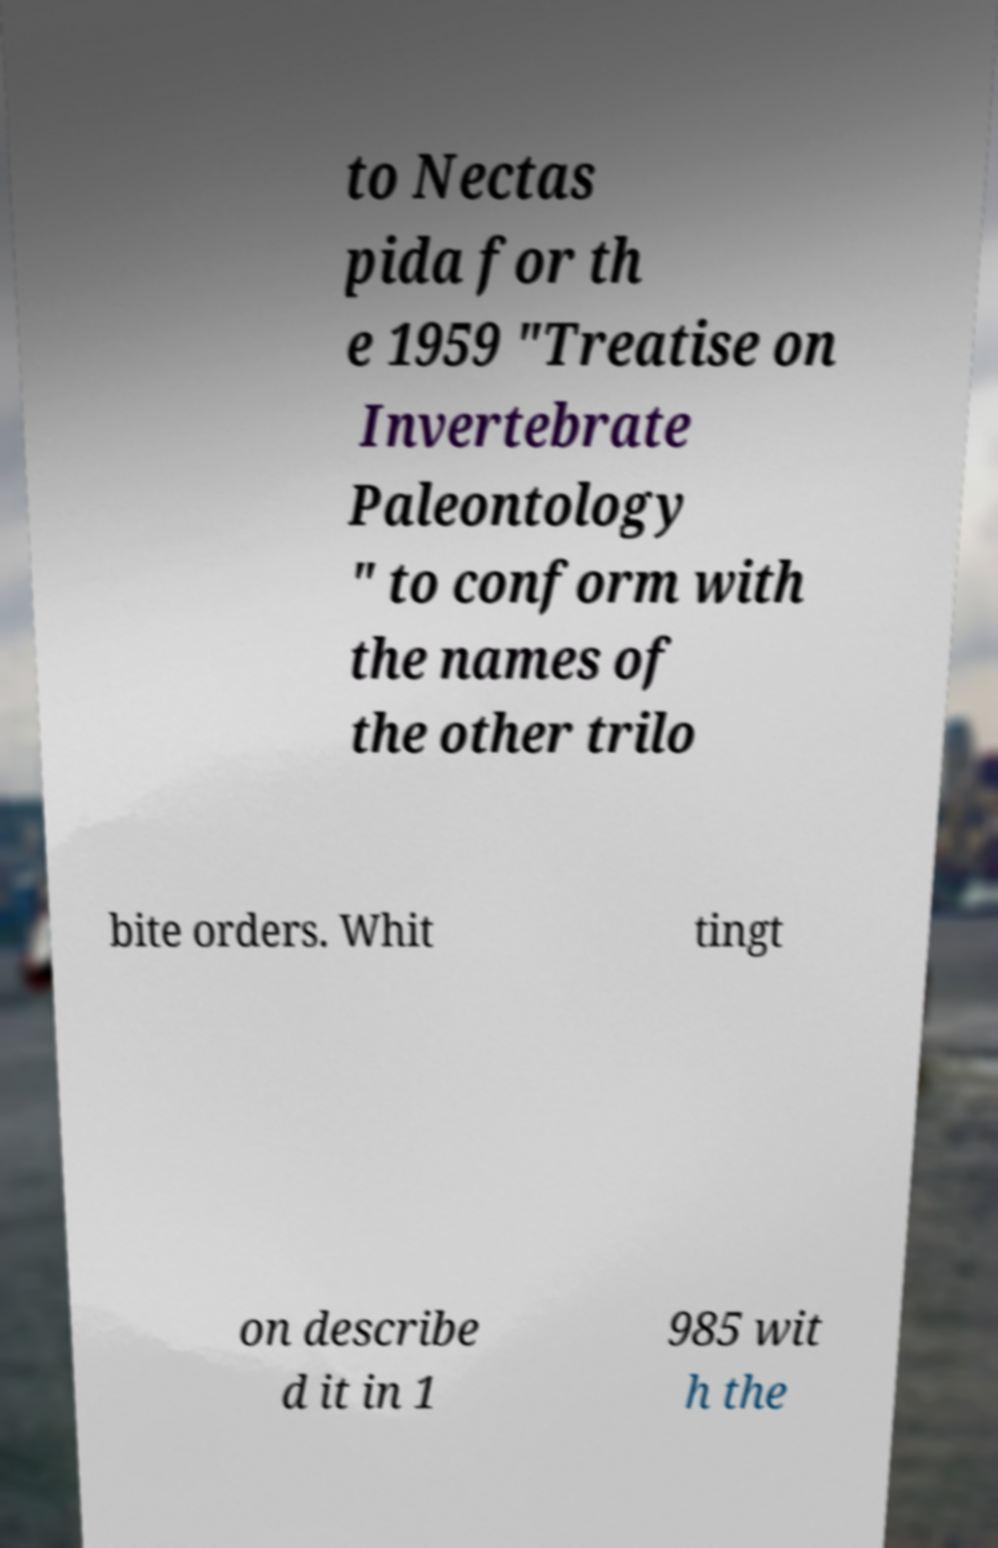There's text embedded in this image that I need extracted. Can you transcribe it verbatim? to Nectas pida for th e 1959 "Treatise on Invertebrate Paleontology " to conform with the names of the other trilo bite orders. Whit tingt on describe d it in 1 985 wit h the 